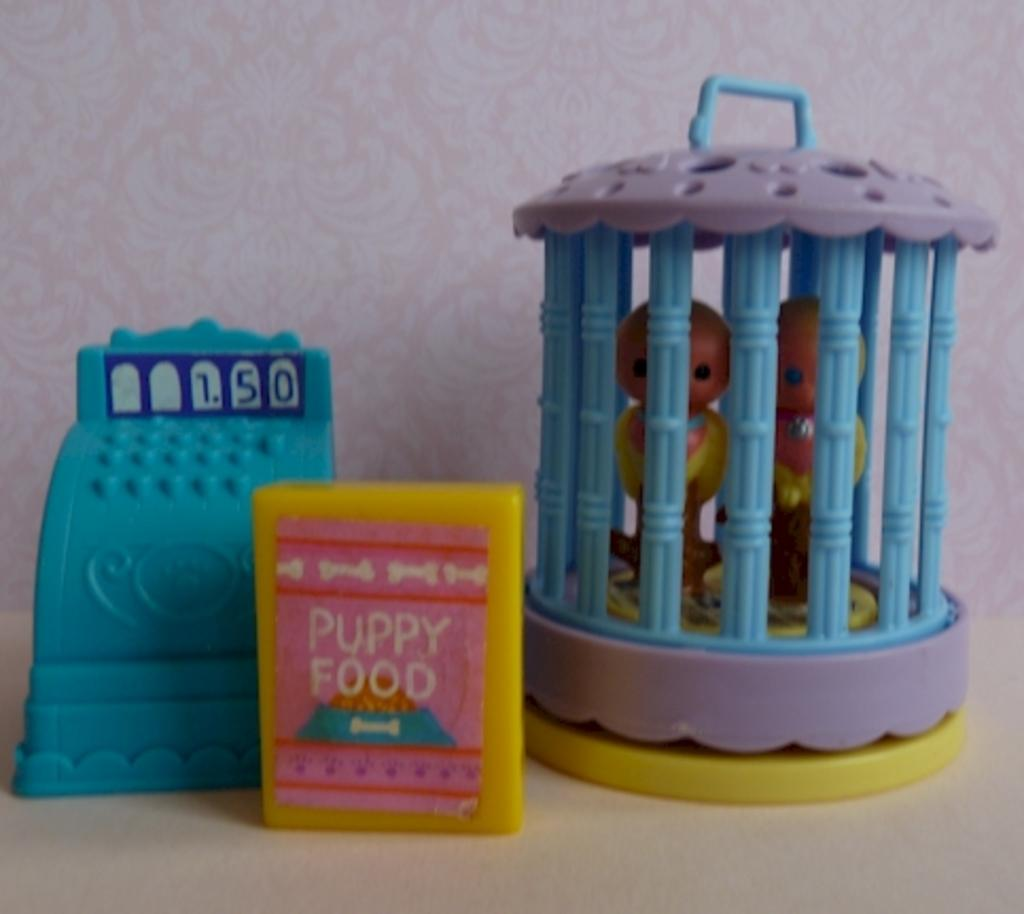What is the color of the box that is visible in the image? The box in the image is yellow. What is placed on the white surface in the image? There are toys placed on a white surface in the image. What is written on the yellow color box? The yellow color box has some text on it. What can be seen in the background of the image? There is a wall in the background of the image. Where is the guide leading the group in the image? There is no guide or group present in the image; it only features a yellow color box, toys, a white surface, and a wall in the background. 